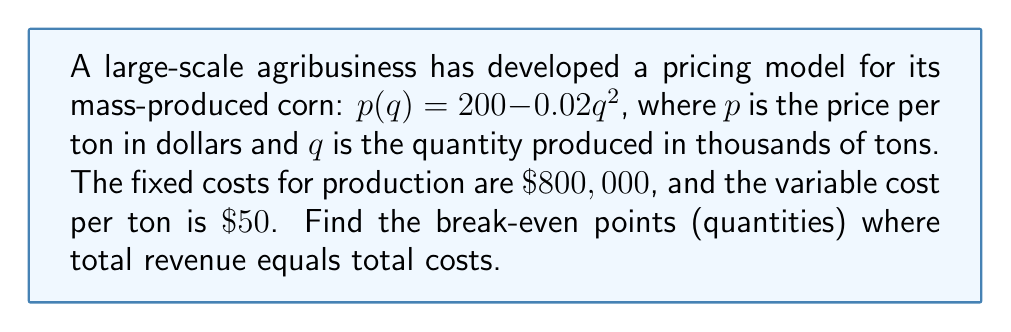What is the answer to this math problem? 1) First, let's set up the equation for total revenue equal to total costs:
   $$ pq = 800000 + 50q $$

2) Substitute the pricing model into the equation:
   $$ (200 - 0.02q^2)q = 800000 + 50q $$

3) Expand the left side:
   $$ 200q - 0.02q^3 = 800000 + 50q $$

4) Rearrange to standard form:
   $$ 0.02q^3 + 150q - 800000 = 0 $$

5) To solve this cubic equation, we need to find its inverse function. Let's substitute $y$ for the left side:
   $$ y = 0.02q^3 + 150q - 800000 $$

6) To find the inverse, swap $q$ and $y$:
   $$ q = 0.02y^3 + 150y - 800000 $$

7) Solve for $y$:
   $$ y^3 = \frac{q + 800000 - 150y}{0.02} $$

8) The break-even points occur when $y = 0$. Substitute this:
   $$ 0 = \frac{q + 800000 - 150(0)}{0.02} $$
   $$ 0 = \frac{q + 800000}{0.02} $$

9) Solve for $q$:
   $$ q + 800000 = 0 $$
   $$ q = -800000 $$

10) Since quantity cannot be negative, there is only one positive break-even point. To find it, we need to solve the original cubic equation:
    $$ 0.02q^3 + 150q - 800000 = 0 $$

11) This can be solved using the cubic formula or a graphing calculator. The positive solution is approximately 63.2457.
Answer: $q \approx 63.2457$ thousand tons 